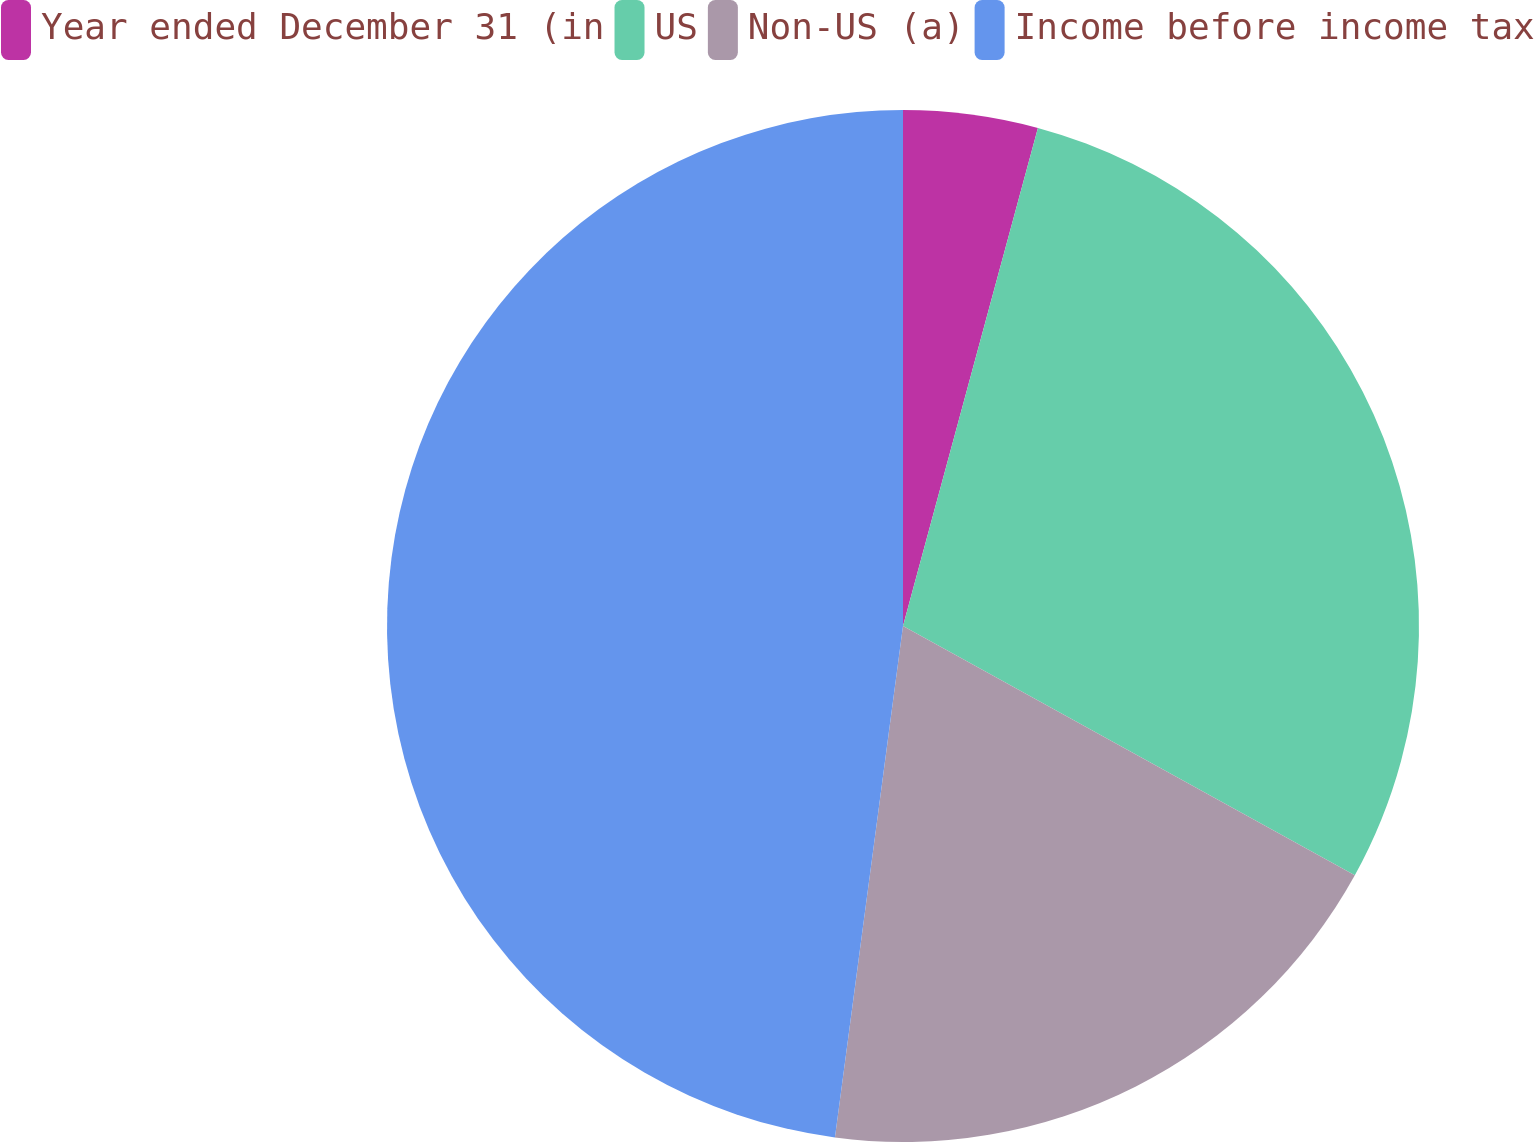Convert chart. <chart><loc_0><loc_0><loc_500><loc_500><pie_chart><fcel>Year ended December 31 (in<fcel>US<fcel>Non-US (a)<fcel>Income before income tax<nl><fcel>4.21%<fcel>28.81%<fcel>19.08%<fcel>47.89%<nl></chart> 